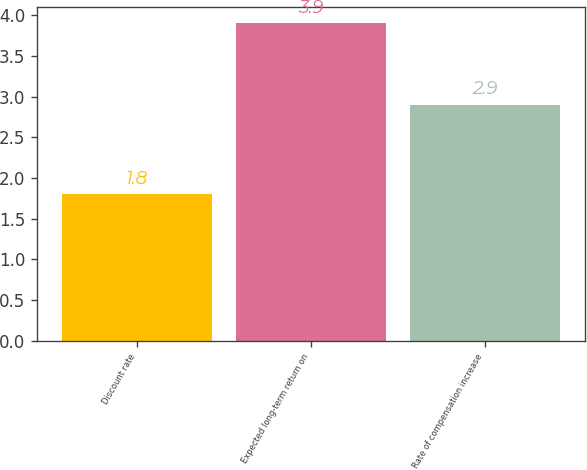Convert chart to OTSL. <chart><loc_0><loc_0><loc_500><loc_500><bar_chart><fcel>Discount rate<fcel>Expected long-term return on<fcel>Rate of compensation increase<nl><fcel>1.8<fcel>3.9<fcel>2.9<nl></chart> 